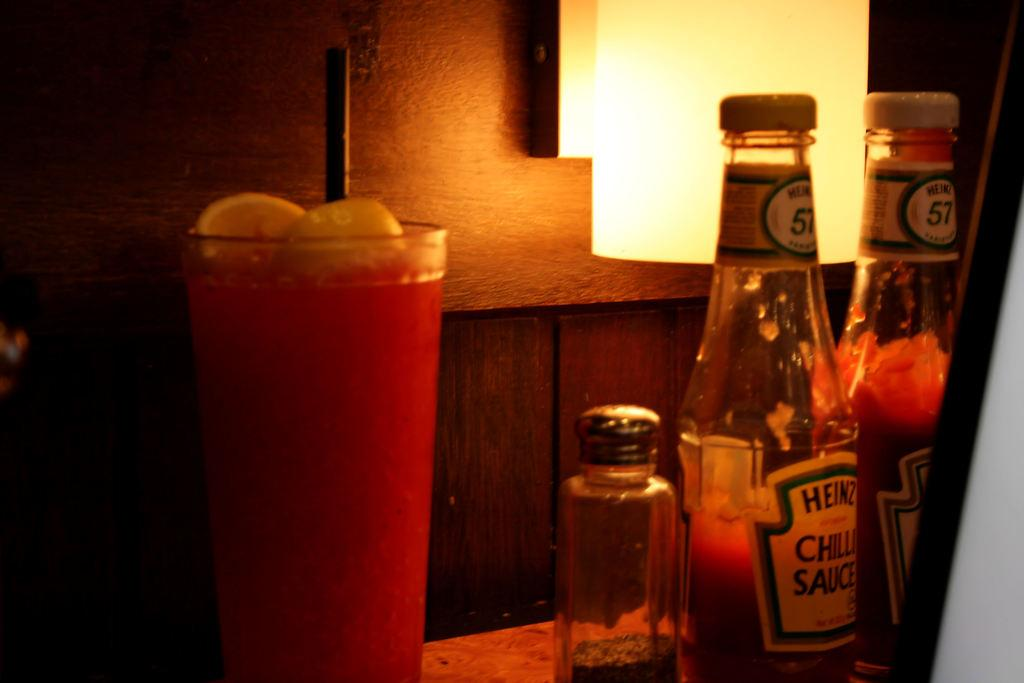What is on the table in the image? There is a glass, a straw, and sauce bottles on the table in the image. What might be used to drink from the glass? The straw on the table could be used to drink from the glass. What is on the right side of the image? There is a board on the right side of the image. What can be seen in the background of the image? There is a light and a wooden wall in the background. How many elbows are visible in the image? There are no elbows visible in the image. What type of furniture is present in the image? The image does not show any furniture; it only shows a table, a board, and a wooden wall. 